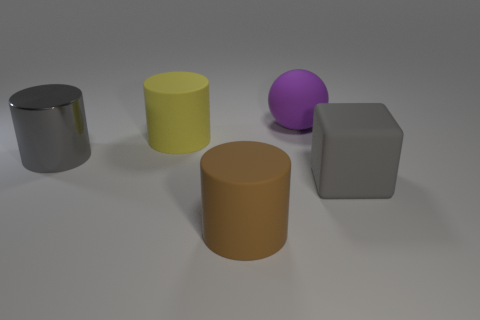There is a yellow object that is the same shape as the large brown object; what is its material?
Your answer should be compact. Rubber. Is there anything else that is the same size as the purple matte ball?
Keep it short and to the point. Yes. Are any purple cylinders visible?
Provide a short and direct response. No. What is the gray object left of the large object in front of the big gray object on the right side of the yellow rubber thing made of?
Ensure brevity in your answer.  Metal. Is the shape of the big yellow rubber object the same as the big gray object that is to the left of the brown rubber object?
Your response must be concise. Yes. What number of tiny green things are the same shape as the large yellow rubber object?
Offer a terse response. 0. What is the shape of the gray shiny thing?
Keep it short and to the point. Cylinder. There is a rubber object behind the big matte cylinder that is behind the big brown object; what size is it?
Your answer should be compact. Large. How many objects are red shiny things or gray things?
Provide a succinct answer. 2. Does the large yellow rubber thing have the same shape as the brown matte thing?
Ensure brevity in your answer.  Yes. 